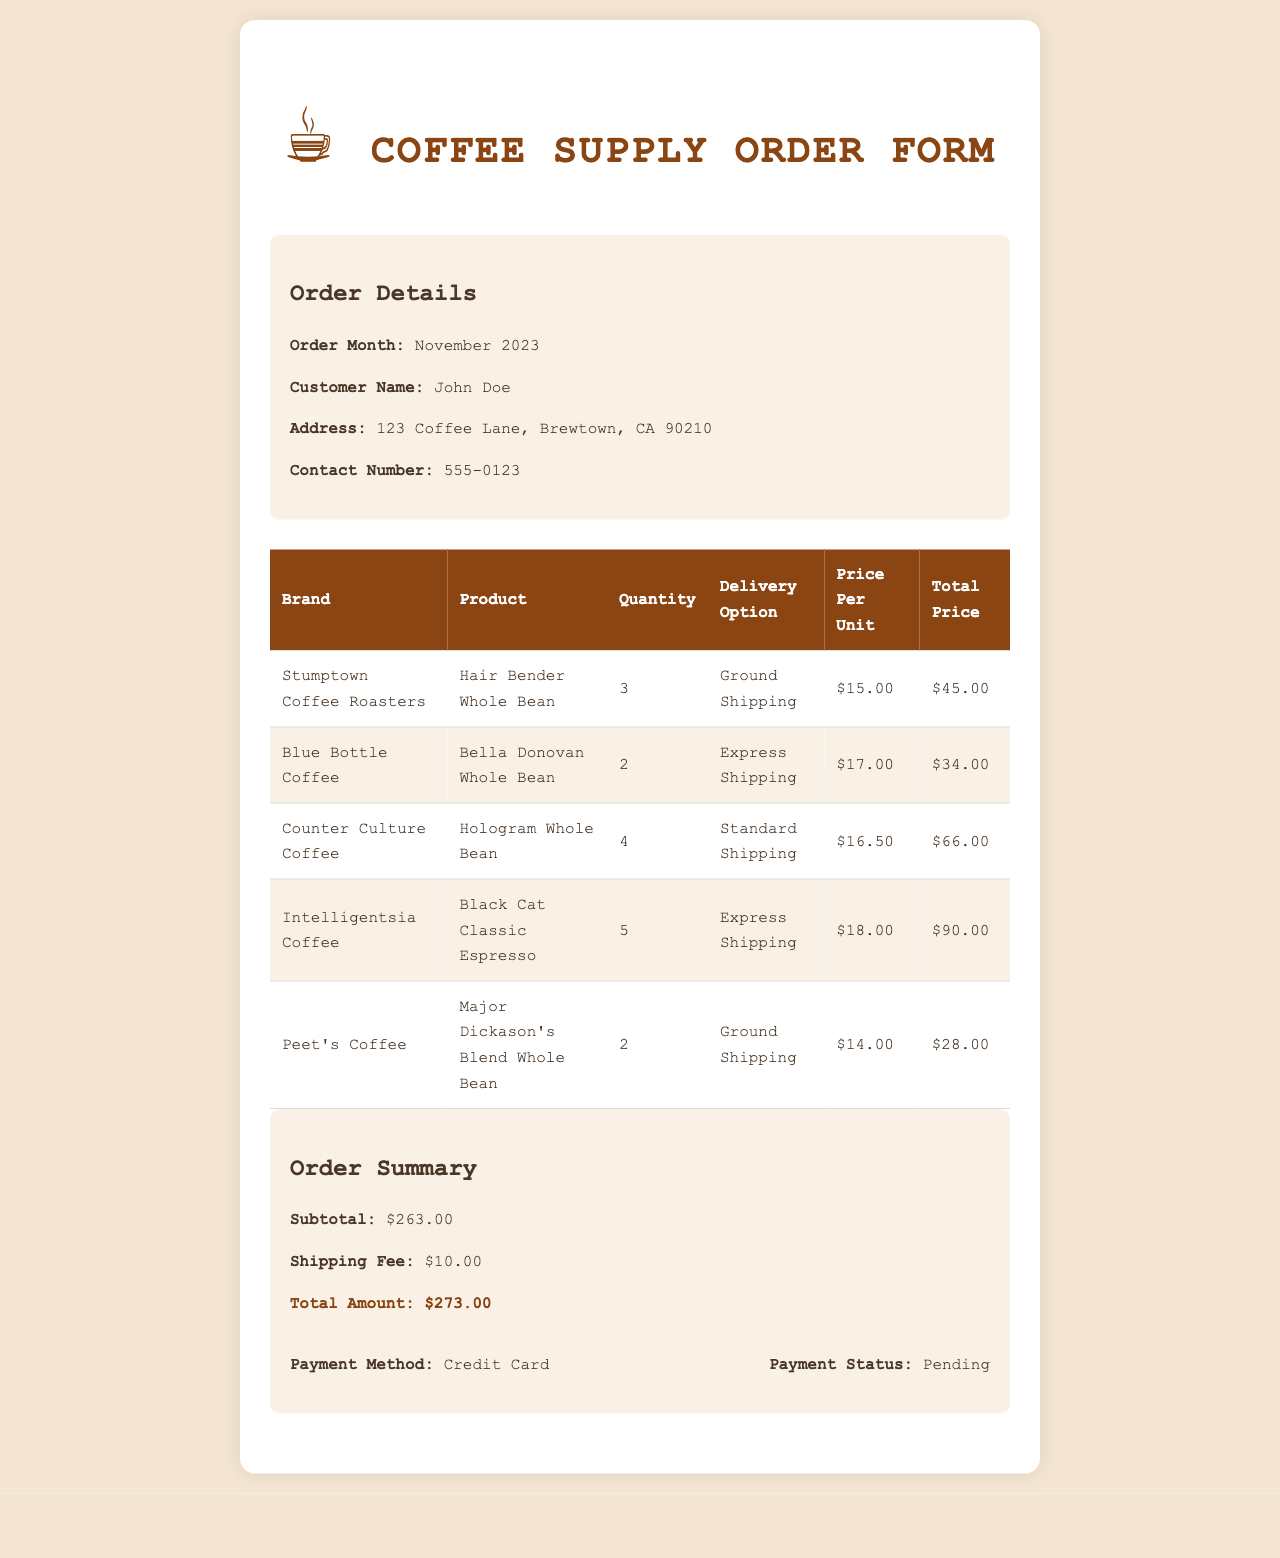What is the customer name? The customer's name is explicitly listed in the order details section of the document.
Answer: John Doe How many units of Bella Donovan Whole Bean are ordered? The quantity for Bella Donovan Whole Bean is specified in the table of order details.
Answer: 2 What is the total price for the Hair Bender Whole Bean? The total price is calculated from the quantity and price per unit for Hair Bender Whole Bean in the document.
Answer: $45.00 What delivery option is chosen for Major Dickason's Blend Whole Bean? The delivery option is provided in the table next to Major Dickason's Blend in the order details.
Answer: Ground Shipping What is the subtotal amount before adding shipping fees? The subtotal is stated in the order summary, representing the sum of the item prices before shipping.
Answer: $263.00 Which brand is associated with the Black Cat Classic Espresso? The brand for Black Cat Classic Espresso can be found in the table correlating to the espresso product.
Answer: Intelligentsia Coffee What month is this order placed for? The order month is specified clearly in the order details section at the top of the document.
Answer: November 2023 What is the shipping fee? The shipping fee is disclosed in the order summary section of the document.
Answer: $10.00 What is the payment status? The payment status is listed in the payment information section of the order summary.
Answer: Pending 